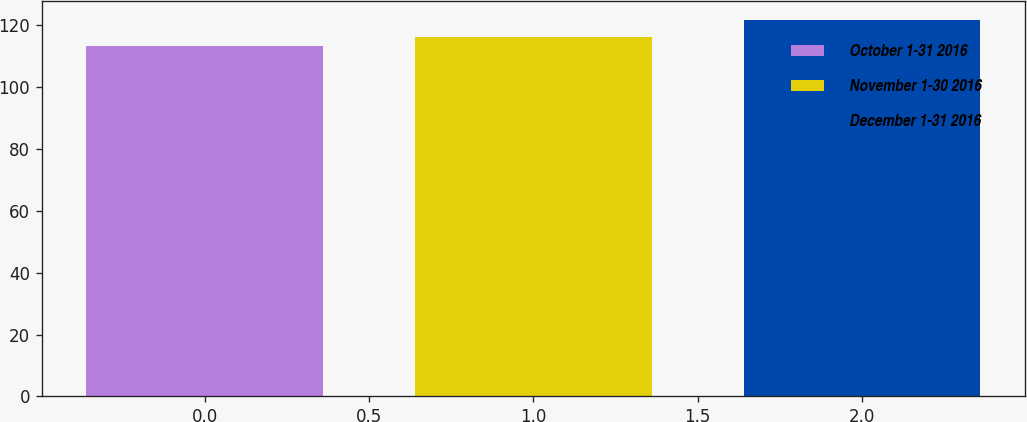Convert chart to OTSL. <chart><loc_0><loc_0><loc_500><loc_500><bar_chart><fcel>October 1-31 2016<fcel>November 1-30 2016<fcel>December 1-31 2016<nl><fcel>113.43<fcel>116.25<fcel>121.76<nl></chart> 